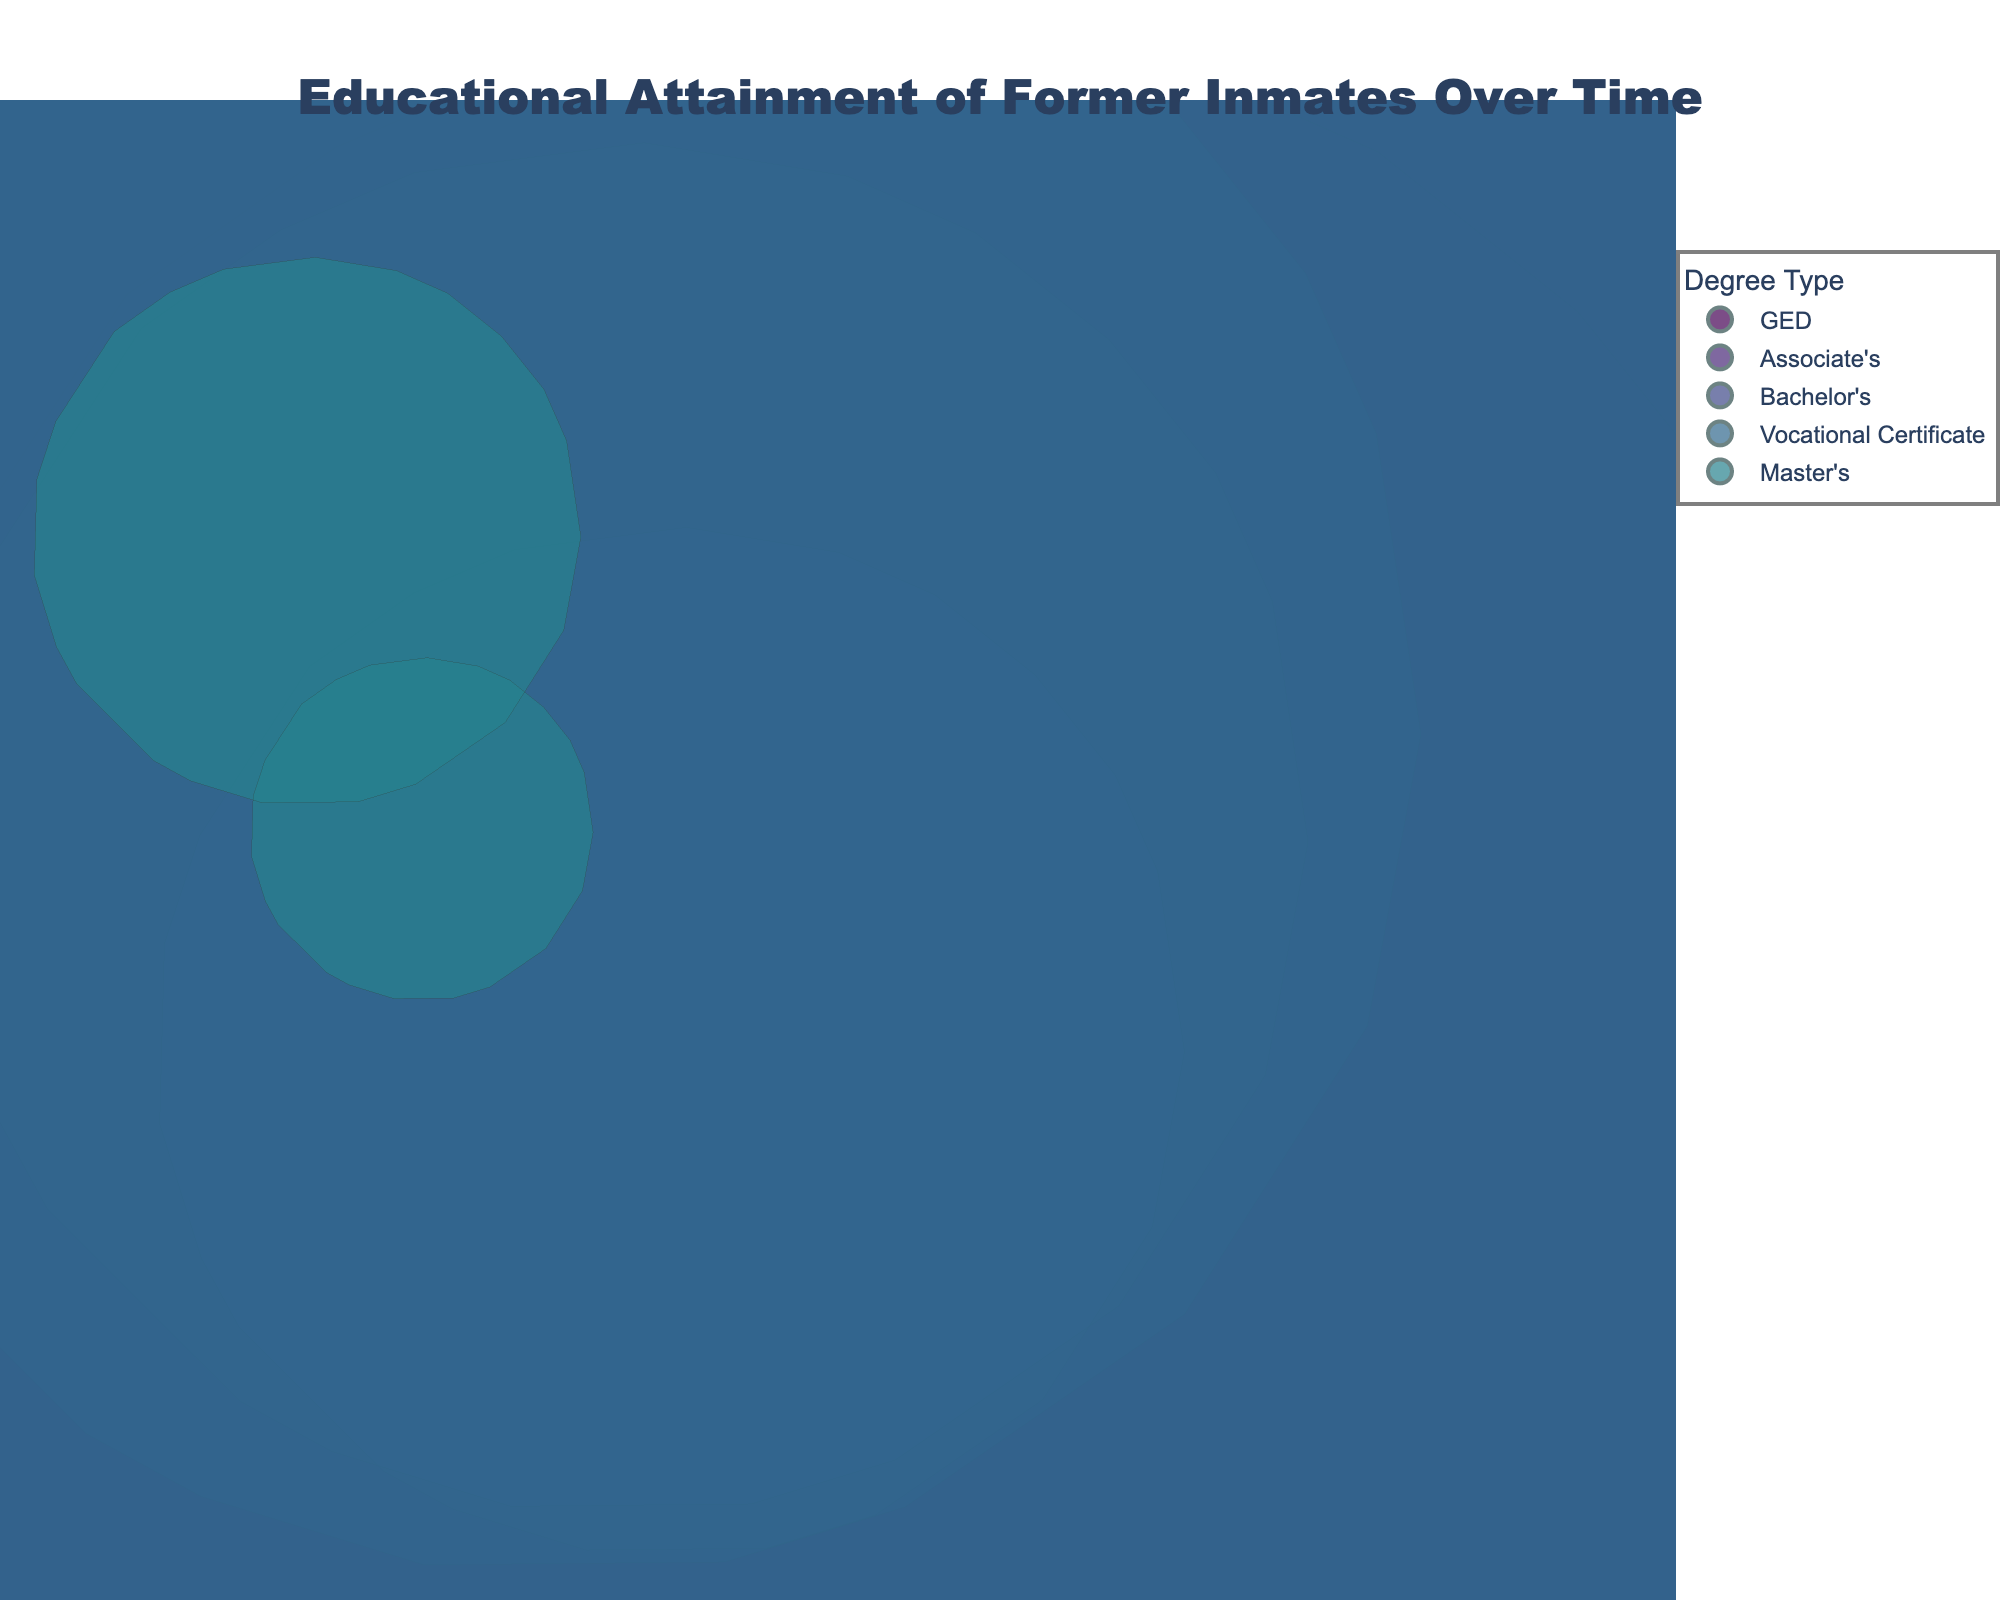What's the highest completion rate achieved by any degree type? The highest completion rate can be found by observing the highest point on the y-axis, which is the completion rate. The highest completion rate is 48%, achieved by GED in the year 2022.
Answer: 48% How has the completion rate for GED changed over the years since 2018? To find this, identify all the data points representing GED and note their completion rates over different years. In 2018, it's 35%, in 2019 it's 38%, in 2020 it's 42%, and in 2022 it's 48%. The completion rate has gradually increased.
Answer: Increased What is the average completion rate for bachelor's degrees over the years provided? Note the completion rates for Bachelor's degrees: 2018: 5%, 2020: 8%, and 2021: 10%. Then, calculate the average: (5 + 8 + 10) / 3 = 23 / 3 ~= 7.67%.
Answer: 7.67% Which degree type has the most number of former inmates completing it in 2021? The number of former inmates is indicated by the size of the bubbles. For 2021, the largest bubble has 650 former inmates, which corresponds to Vocational Certificates.
Answer: Vocational Certificates Is there any degree type that consistently appears every year from 2018 to 2022? Check the degree types listed for each year. GED is the only degree type that appears in every year from 2018 to 2022.
Answer: GED Compare the completion rates of Vocational Certificates between 2019 and 2021. Which year had a higher rate? The completion rate for Vocational Certificates in 2019 is 40%, while in 2021, it is 45%. Thus, 2021 had a higher rate.
Answer: 2021 Which degree type had the longest time since release in the dataset? The x-axis represents "Time Since Release (Years)" and the dot farthest to the right corresponds to the degree type. Master's degrees in 2020 and 2022 had the longest time since release, both 8 and 9 years respectively.
Answer: Master's What is the total number of former inmates who completed Associate's degrees across all years? Sum the number of former inmates for Associate's degrees across all years: 300 (2018) + 350 (2019) + 400 (2021) + 450 (2022) = 1500.
Answer: 1500 Which year had the highest completion rate for any degree type? Check the maximum point on the y-axis for each year. The highest completion rate corresponds to the point at 48% in the year 2022.
Answer: 2022 How does the completion rate in 2019 for Associate's degrees compare to that in 2022? The completion rate for Associate's degrees in 2019 is 15%, while in 2022, it is 22%. Thus, the completion rate increased in 2022.
Answer: Increased 